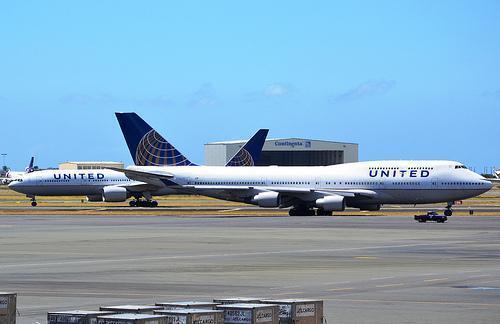How many planes are there?
Give a very brief answer. 2. How many boxes are there?
Give a very brief answer. 8. 